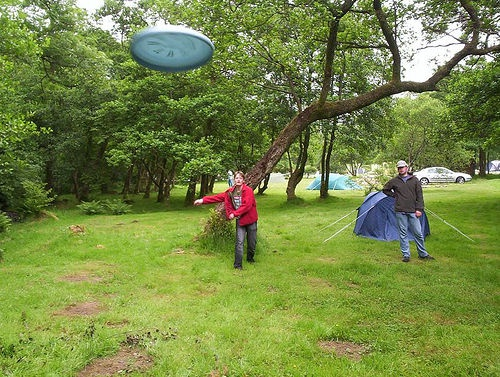Describe the objects in this image and their specific colors. I can see frisbee in khaki, gray, teal, and white tones, people in khaki, gray, and black tones, people in khaki, brown, black, and gray tones, and car in khaki, white, darkgray, gray, and black tones in this image. 